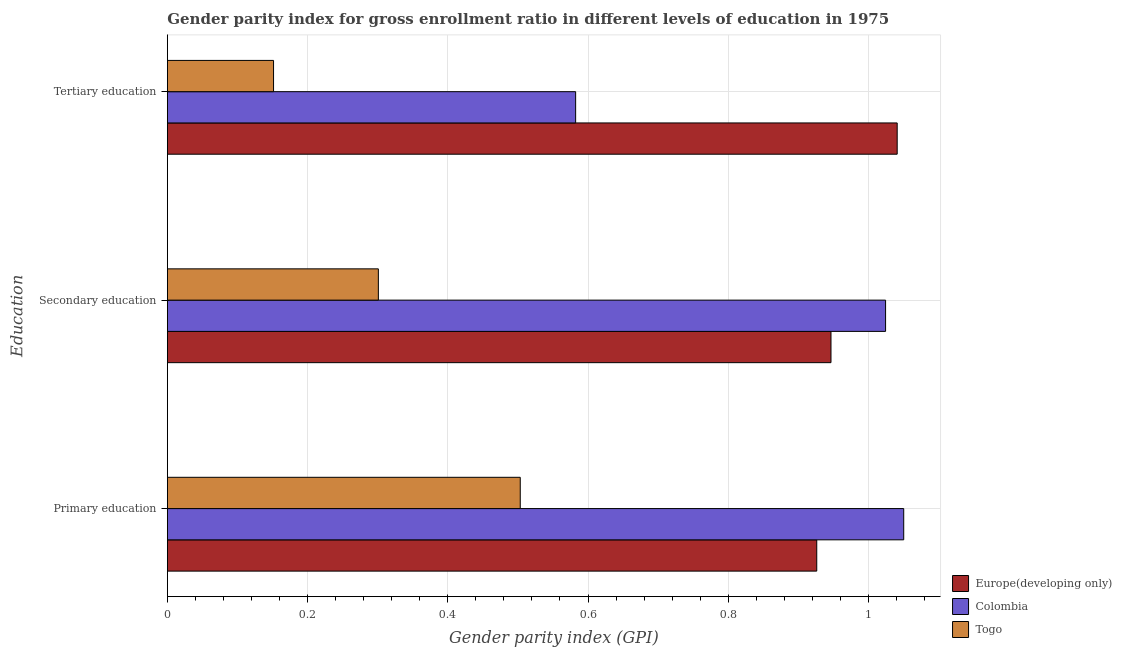How many different coloured bars are there?
Keep it short and to the point. 3. What is the label of the 2nd group of bars from the top?
Make the answer very short. Secondary education. What is the gender parity index in tertiary education in Colombia?
Your answer should be compact. 0.58. Across all countries, what is the maximum gender parity index in tertiary education?
Your response must be concise. 1.04. Across all countries, what is the minimum gender parity index in tertiary education?
Your response must be concise. 0.15. In which country was the gender parity index in tertiary education maximum?
Offer a terse response. Europe(developing only). In which country was the gender parity index in tertiary education minimum?
Give a very brief answer. Togo. What is the total gender parity index in tertiary education in the graph?
Your answer should be compact. 1.77. What is the difference between the gender parity index in primary education in Togo and that in Europe(developing only)?
Your answer should be compact. -0.42. What is the difference between the gender parity index in tertiary education in Europe(developing only) and the gender parity index in secondary education in Colombia?
Offer a terse response. 0.02. What is the average gender parity index in primary education per country?
Offer a very short reply. 0.83. What is the difference between the gender parity index in primary education and gender parity index in secondary education in Europe(developing only)?
Ensure brevity in your answer.  -0.02. What is the ratio of the gender parity index in tertiary education in Togo to that in Colombia?
Your answer should be very brief. 0.26. Is the gender parity index in tertiary education in Togo less than that in Europe(developing only)?
Your answer should be very brief. Yes. What is the difference between the highest and the second highest gender parity index in tertiary education?
Keep it short and to the point. 0.46. What is the difference between the highest and the lowest gender parity index in tertiary education?
Your response must be concise. 0.89. In how many countries, is the gender parity index in secondary education greater than the average gender parity index in secondary education taken over all countries?
Provide a succinct answer. 2. Is the sum of the gender parity index in primary education in Colombia and Togo greater than the maximum gender parity index in secondary education across all countries?
Give a very brief answer. Yes. What does the 1st bar from the top in Secondary education represents?
Your answer should be compact. Togo. What does the 3rd bar from the bottom in Tertiary education represents?
Offer a terse response. Togo. Is it the case that in every country, the sum of the gender parity index in primary education and gender parity index in secondary education is greater than the gender parity index in tertiary education?
Make the answer very short. Yes. Does the graph contain any zero values?
Your response must be concise. No. Does the graph contain grids?
Your response must be concise. Yes. How many legend labels are there?
Provide a short and direct response. 3. How are the legend labels stacked?
Your answer should be very brief. Vertical. What is the title of the graph?
Keep it short and to the point. Gender parity index for gross enrollment ratio in different levels of education in 1975. What is the label or title of the X-axis?
Your answer should be very brief. Gender parity index (GPI). What is the label or title of the Y-axis?
Keep it short and to the point. Education. What is the Gender parity index (GPI) in Europe(developing only) in Primary education?
Make the answer very short. 0.93. What is the Gender parity index (GPI) in Colombia in Primary education?
Offer a terse response. 1.05. What is the Gender parity index (GPI) of Togo in Primary education?
Provide a succinct answer. 0.5. What is the Gender parity index (GPI) of Europe(developing only) in Secondary education?
Your answer should be very brief. 0.95. What is the Gender parity index (GPI) in Colombia in Secondary education?
Offer a terse response. 1.02. What is the Gender parity index (GPI) of Togo in Secondary education?
Ensure brevity in your answer.  0.3. What is the Gender parity index (GPI) in Europe(developing only) in Tertiary education?
Your answer should be compact. 1.04. What is the Gender parity index (GPI) in Colombia in Tertiary education?
Your answer should be very brief. 0.58. What is the Gender parity index (GPI) in Togo in Tertiary education?
Make the answer very short. 0.15. Across all Education, what is the maximum Gender parity index (GPI) in Europe(developing only)?
Your response must be concise. 1.04. Across all Education, what is the maximum Gender parity index (GPI) in Colombia?
Give a very brief answer. 1.05. Across all Education, what is the maximum Gender parity index (GPI) of Togo?
Provide a succinct answer. 0.5. Across all Education, what is the minimum Gender parity index (GPI) in Europe(developing only)?
Your answer should be very brief. 0.93. Across all Education, what is the minimum Gender parity index (GPI) in Colombia?
Keep it short and to the point. 0.58. Across all Education, what is the minimum Gender parity index (GPI) in Togo?
Offer a very short reply. 0.15. What is the total Gender parity index (GPI) of Europe(developing only) in the graph?
Your answer should be compact. 2.91. What is the total Gender parity index (GPI) in Colombia in the graph?
Offer a very short reply. 2.66. What is the total Gender parity index (GPI) of Togo in the graph?
Keep it short and to the point. 0.96. What is the difference between the Gender parity index (GPI) in Europe(developing only) in Primary education and that in Secondary education?
Keep it short and to the point. -0.02. What is the difference between the Gender parity index (GPI) of Colombia in Primary education and that in Secondary education?
Provide a short and direct response. 0.03. What is the difference between the Gender parity index (GPI) in Togo in Primary education and that in Secondary education?
Your answer should be very brief. 0.2. What is the difference between the Gender parity index (GPI) of Europe(developing only) in Primary education and that in Tertiary education?
Give a very brief answer. -0.11. What is the difference between the Gender parity index (GPI) in Colombia in Primary education and that in Tertiary education?
Provide a succinct answer. 0.47. What is the difference between the Gender parity index (GPI) in Togo in Primary education and that in Tertiary education?
Provide a succinct answer. 0.35. What is the difference between the Gender parity index (GPI) in Europe(developing only) in Secondary education and that in Tertiary education?
Provide a short and direct response. -0.09. What is the difference between the Gender parity index (GPI) in Colombia in Secondary education and that in Tertiary education?
Make the answer very short. 0.44. What is the difference between the Gender parity index (GPI) in Togo in Secondary education and that in Tertiary education?
Ensure brevity in your answer.  0.15. What is the difference between the Gender parity index (GPI) of Europe(developing only) in Primary education and the Gender parity index (GPI) of Colombia in Secondary education?
Provide a short and direct response. -0.1. What is the difference between the Gender parity index (GPI) of Europe(developing only) in Primary education and the Gender parity index (GPI) of Togo in Secondary education?
Make the answer very short. 0.63. What is the difference between the Gender parity index (GPI) of Colombia in Primary education and the Gender parity index (GPI) of Togo in Secondary education?
Your response must be concise. 0.75. What is the difference between the Gender parity index (GPI) in Europe(developing only) in Primary education and the Gender parity index (GPI) in Colombia in Tertiary education?
Ensure brevity in your answer.  0.34. What is the difference between the Gender parity index (GPI) of Europe(developing only) in Primary education and the Gender parity index (GPI) of Togo in Tertiary education?
Your answer should be compact. 0.77. What is the difference between the Gender parity index (GPI) in Colombia in Primary education and the Gender parity index (GPI) in Togo in Tertiary education?
Give a very brief answer. 0.9. What is the difference between the Gender parity index (GPI) in Europe(developing only) in Secondary education and the Gender parity index (GPI) in Colombia in Tertiary education?
Give a very brief answer. 0.36. What is the difference between the Gender parity index (GPI) of Europe(developing only) in Secondary education and the Gender parity index (GPI) of Togo in Tertiary education?
Offer a very short reply. 0.8. What is the difference between the Gender parity index (GPI) in Colombia in Secondary education and the Gender parity index (GPI) in Togo in Tertiary education?
Make the answer very short. 0.87. What is the average Gender parity index (GPI) of Europe(developing only) per Education?
Provide a short and direct response. 0.97. What is the average Gender parity index (GPI) of Colombia per Education?
Give a very brief answer. 0.89. What is the average Gender parity index (GPI) of Togo per Education?
Keep it short and to the point. 0.32. What is the difference between the Gender parity index (GPI) in Europe(developing only) and Gender parity index (GPI) in Colombia in Primary education?
Give a very brief answer. -0.12. What is the difference between the Gender parity index (GPI) of Europe(developing only) and Gender parity index (GPI) of Togo in Primary education?
Your answer should be compact. 0.42. What is the difference between the Gender parity index (GPI) of Colombia and Gender parity index (GPI) of Togo in Primary education?
Give a very brief answer. 0.55. What is the difference between the Gender parity index (GPI) of Europe(developing only) and Gender parity index (GPI) of Colombia in Secondary education?
Your answer should be compact. -0.08. What is the difference between the Gender parity index (GPI) in Europe(developing only) and Gender parity index (GPI) in Togo in Secondary education?
Give a very brief answer. 0.65. What is the difference between the Gender parity index (GPI) in Colombia and Gender parity index (GPI) in Togo in Secondary education?
Provide a short and direct response. 0.72. What is the difference between the Gender parity index (GPI) of Europe(developing only) and Gender parity index (GPI) of Colombia in Tertiary education?
Provide a succinct answer. 0.46. What is the difference between the Gender parity index (GPI) in Europe(developing only) and Gender parity index (GPI) in Togo in Tertiary education?
Keep it short and to the point. 0.89. What is the difference between the Gender parity index (GPI) in Colombia and Gender parity index (GPI) in Togo in Tertiary education?
Ensure brevity in your answer.  0.43. What is the ratio of the Gender parity index (GPI) in Europe(developing only) in Primary education to that in Secondary education?
Provide a short and direct response. 0.98. What is the ratio of the Gender parity index (GPI) of Colombia in Primary education to that in Secondary education?
Your answer should be compact. 1.03. What is the ratio of the Gender parity index (GPI) in Togo in Primary education to that in Secondary education?
Your answer should be very brief. 1.67. What is the ratio of the Gender parity index (GPI) in Europe(developing only) in Primary education to that in Tertiary education?
Your answer should be very brief. 0.89. What is the ratio of the Gender parity index (GPI) of Colombia in Primary education to that in Tertiary education?
Make the answer very short. 1.8. What is the ratio of the Gender parity index (GPI) of Togo in Primary education to that in Tertiary education?
Provide a succinct answer. 3.32. What is the ratio of the Gender parity index (GPI) in Europe(developing only) in Secondary education to that in Tertiary education?
Provide a succinct answer. 0.91. What is the ratio of the Gender parity index (GPI) in Colombia in Secondary education to that in Tertiary education?
Your answer should be compact. 1.76. What is the ratio of the Gender parity index (GPI) in Togo in Secondary education to that in Tertiary education?
Provide a succinct answer. 1.99. What is the difference between the highest and the second highest Gender parity index (GPI) in Europe(developing only)?
Offer a very short reply. 0.09. What is the difference between the highest and the second highest Gender parity index (GPI) of Colombia?
Give a very brief answer. 0.03. What is the difference between the highest and the second highest Gender parity index (GPI) in Togo?
Offer a very short reply. 0.2. What is the difference between the highest and the lowest Gender parity index (GPI) in Europe(developing only)?
Give a very brief answer. 0.11. What is the difference between the highest and the lowest Gender parity index (GPI) in Colombia?
Make the answer very short. 0.47. What is the difference between the highest and the lowest Gender parity index (GPI) in Togo?
Your response must be concise. 0.35. 